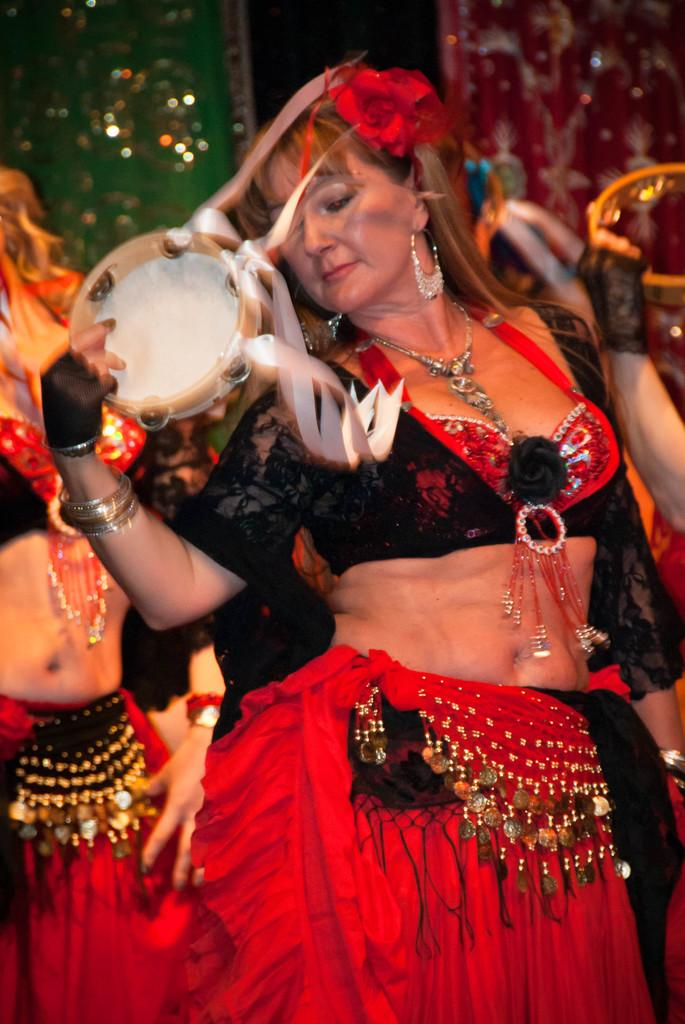What is the main subject of the image? The main subject of the image is a woman. What is the woman doing in the image? The woman is dancing in the image. What is the woman holding in her hand? The woman is holding a drum-like object in her hand. Are there any other people in the image? Yes, there are other women dancing in the image. What type of pancake is being flipped in the image? There is no pancake present in the image; the woman is holding a drum-like object. How does the image show an increase in the number of dancers? The image does not show an increase in the number of dancers; it only shows the woman and other women who are already dancing. 